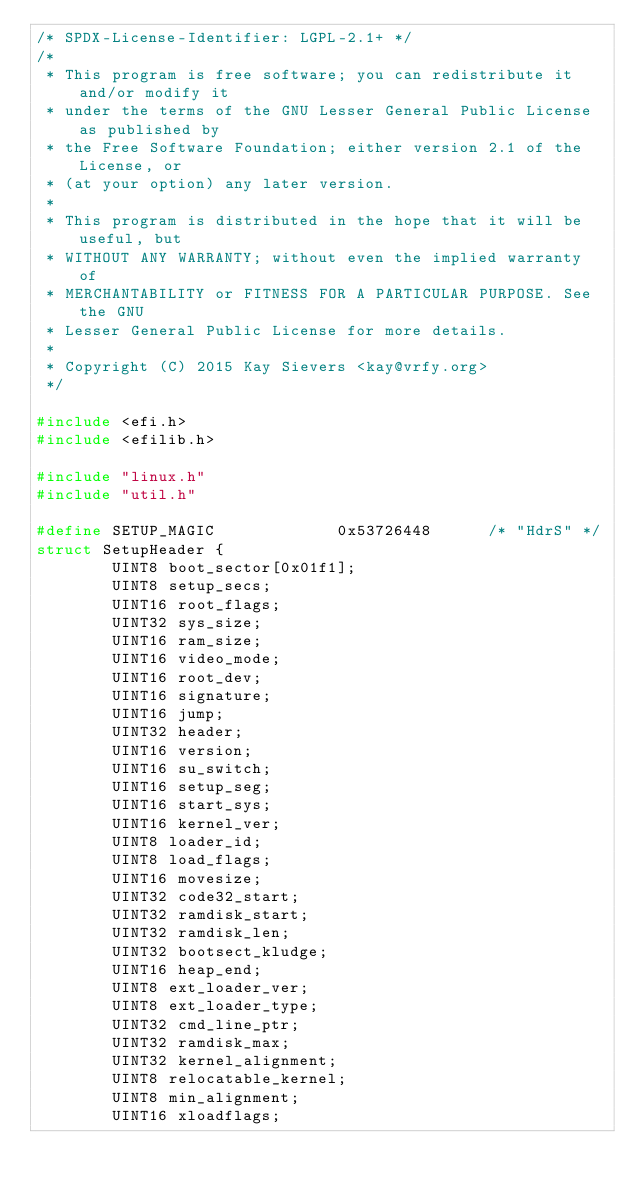Convert code to text. <code><loc_0><loc_0><loc_500><loc_500><_C_>/* SPDX-License-Identifier: LGPL-2.1+ */
/*
 * This program is free software; you can redistribute it and/or modify it
 * under the terms of the GNU Lesser General Public License as published by
 * the Free Software Foundation; either version 2.1 of the License, or
 * (at your option) any later version.
 *
 * This program is distributed in the hope that it will be useful, but
 * WITHOUT ANY WARRANTY; without even the implied warranty of
 * MERCHANTABILITY or FITNESS FOR A PARTICULAR PURPOSE. See the GNU
 * Lesser General Public License for more details.
 *
 * Copyright (C) 2015 Kay Sievers <kay@vrfy.org>
 */

#include <efi.h>
#include <efilib.h>

#include "linux.h"
#include "util.h"

#define SETUP_MAGIC             0x53726448      /* "HdrS" */
struct SetupHeader {
        UINT8 boot_sector[0x01f1];
        UINT8 setup_secs;
        UINT16 root_flags;
        UINT32 sys_size;
        UINT16 ram_size;
        UINT16 video_mode;
        UINT16 root_dev;
        UINT16 signature;
        UINT16 jump;
        UINT32 header;
        UINT16 version;
        UINT16 su_switch;
        UINT16 setup_seg;
        UINT16 start_sys;
        UINT16 kernel_ver;
        UINT8 loader_id;
        UINT8 load_flags;
        UINT16 movesize;
        UINT32 code32_start;
        UINT32 ramdisk_start;
        UINT32 ramdisk_len;
        UINT32 bootsect_kludge;
        UINT16 heap_end;
        UINT8 ext_loader_ver;
        UINT8 ext_loader_type;
        UINT32 cmd_line_ptr;
        UINT32 ramdisk_max;
        UINT32 kernel_alignment;
        UINT8 relocatable_kernel;
        UINT8 min_alignment;
        UINT16 xloadflags;</code> 